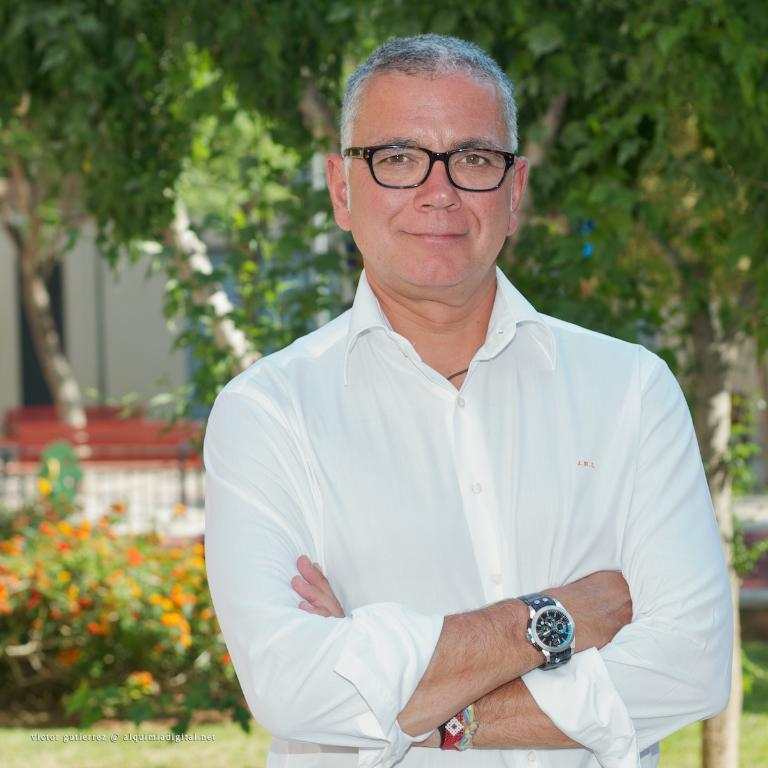What is the main subject of the image? There is a man standing in the center of the image. What can be seen in the background of the image? There are trees, a building, plants, and grass in the background of the image. What type of treatment is the man receiving in the image? There is no indication in the image that the man is receiving any treatment. What type of grain can be seen growing in the image? There is no grain visible in the image. 